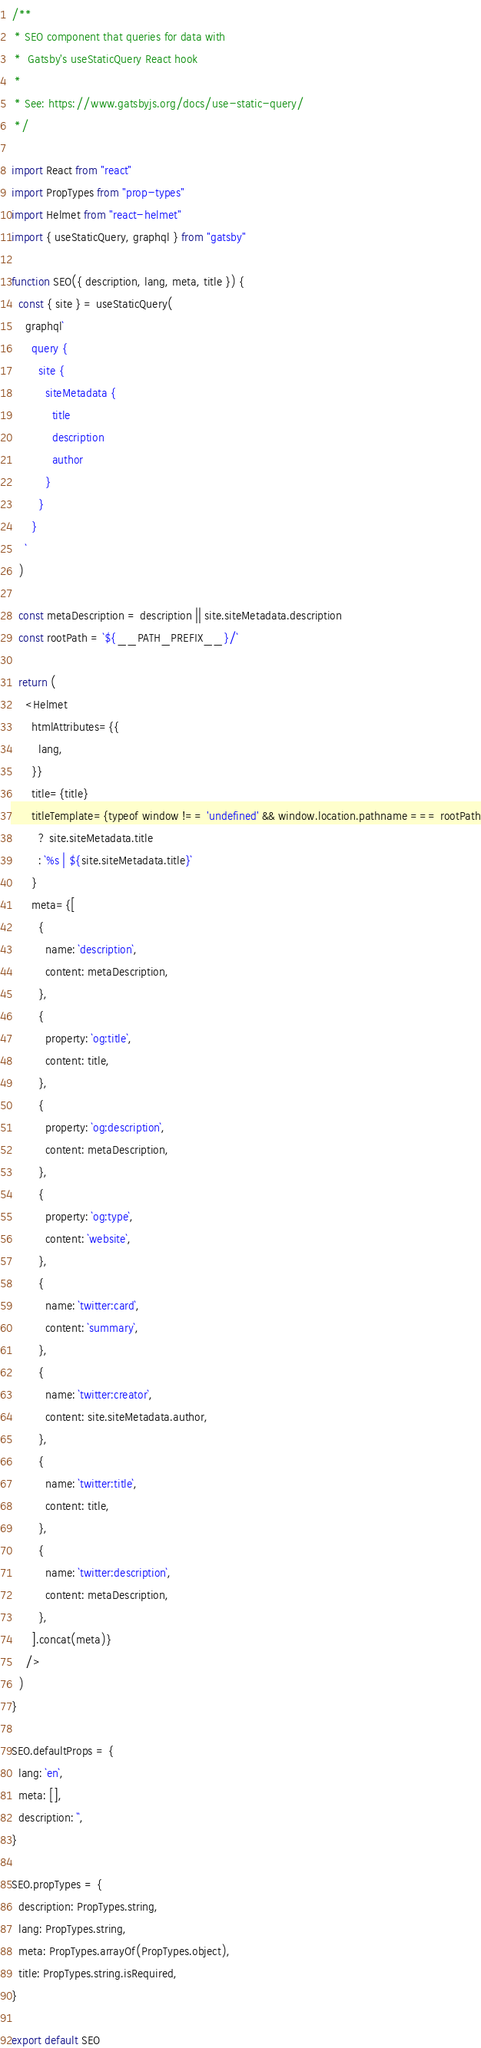Convert code to text. <code><loc_0><loc_0><loc_500><loc_500><_JavaScript_>/**
 * SEO component that queries for data with
 *  Gatsby's useStaticQuery React hook
 *
 * See: https://www.gatsbyjs.org/docs/use-static-query/
 */

import React from "react"
import PropTypes from "prop-types"
import Helmet from "react-helmet"
import { useStaticQuery, graphql } from "gatsby"

function SEO({ description, lang, meta, title }) {
  const { site } = useStaticQuery(
    graphql`
      query {
        site {
          siteMetadata {
            title
            description
            author
          }
        }
      }
    `
  )

  const metaDescription = description || site.siteMetadata.description
  const rootPath = `${__PATH_PREFIX__}/`

  return (
    <Helmet
      htmlAttributes={{
        lang,
      }}
      title={title}
      titleTemplate={typeof window !== 'undefined' && window.location.pathname === rootPath
        ? site.siteMetadata.title
        : `%s | ${site.siteMetadata.title}`
      }
      meta={[
        {
          name: `description`,
          content: metaDescription,
        },
        {
          property: `og:title`,
          content: title,
        },
        {
          property: `og:description`,
          content: metaDescription,
        },
        {
          property: `og:type`,
          content: `website`,
        },
        {
          name: `twitter:card`,
          content: `summary`,
        },
        {
          name: `twitter:creator`,
          content: site.siteMetadata.author,
        },
        {
          name: `twitter:title`,
          content: title,
        },
        {
          name: `twitter:description`,
          content: metaDescription,
        },
      ].concat(meta)}
    />
  )
}

SEO.defaultProps = {
  lang: `en`,
  meta: [],
  description: ``,
}

SEO.propTypes = {
  description: PropTypes.string,
  lang: PropTypes.string,
  meta: PropTypes.arrayOf(PropTypes.object),
  title: PropTypes.string.isRequired,
}

export default SEO
</code> 